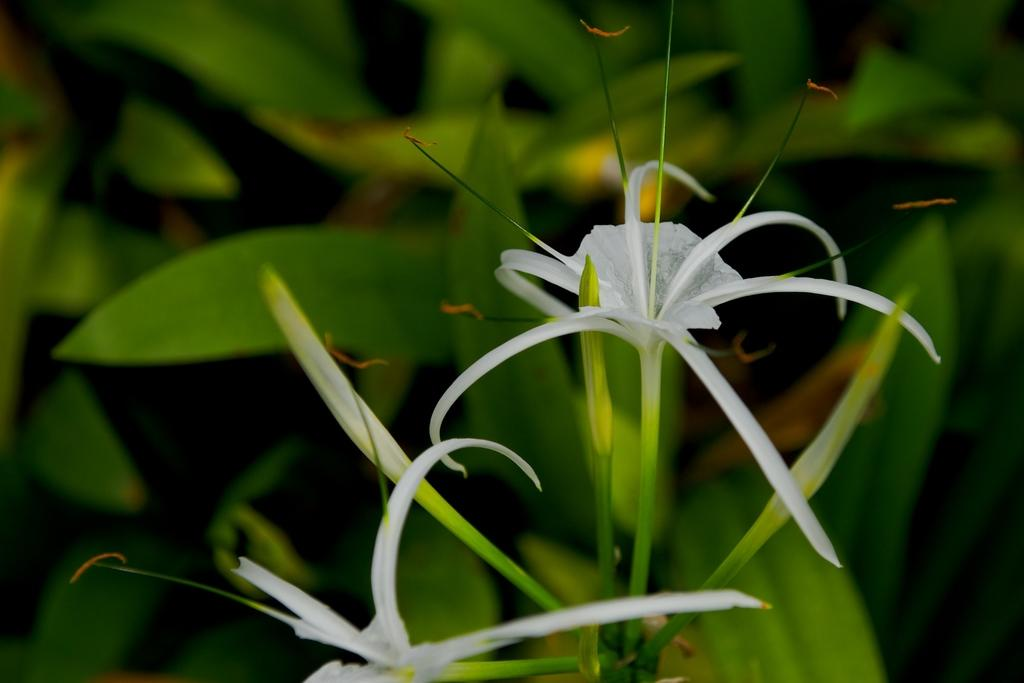What type of flora can be seen in the image? There are flowers in the image. What color are the flowers? The flowers are white. What else is present in the image besides the flowers? There is a plant in the image. What color is the plant? The plant is green. Can you see a hole in the center of the flowers? There is no hole present in the center of the flowers; they are solid white petals. 